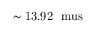<formula> <loc_0><loc_0><loc_500><loc_500>{ \sim 1 3 . 9 2 \ \ m u s }</formula> 